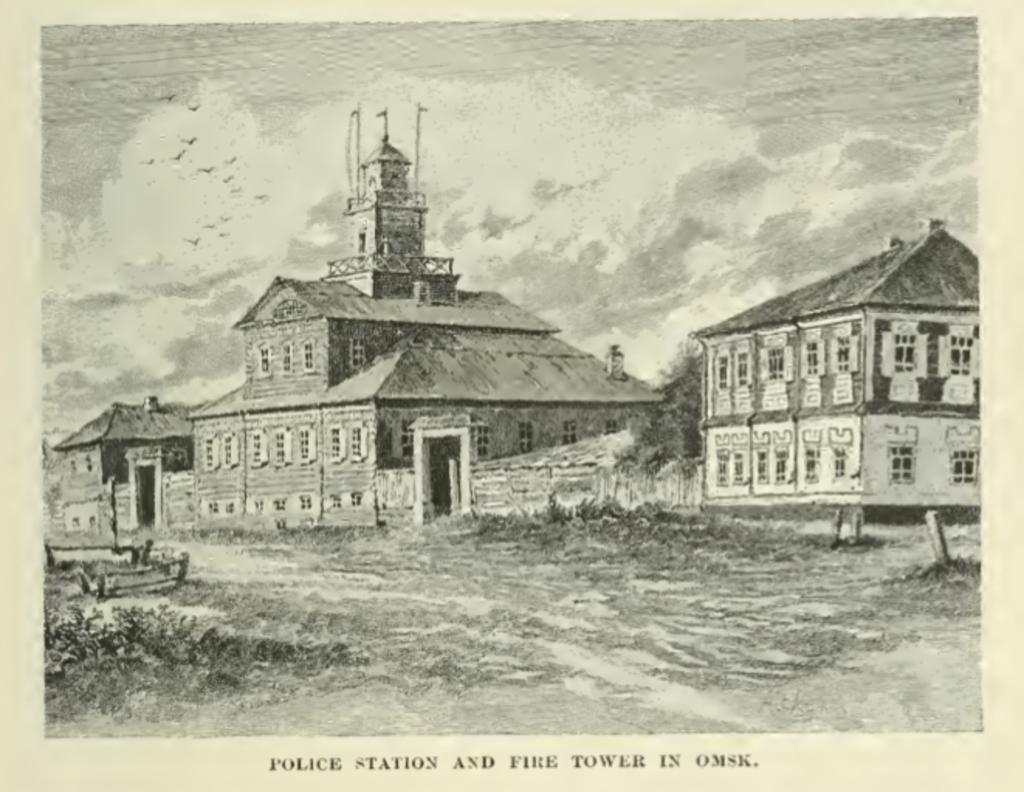What type of picture is in the image? The image contains a black and white picture. What can be seen in the picture? There is a group of buildings and trees in the picture. What other objects are present in the picture? There are poles in the picture. What is visible in the background of the picture? The sky is visible in the background of the picture. How many apples are on the ground in the image? There are no apples visible in the image. 